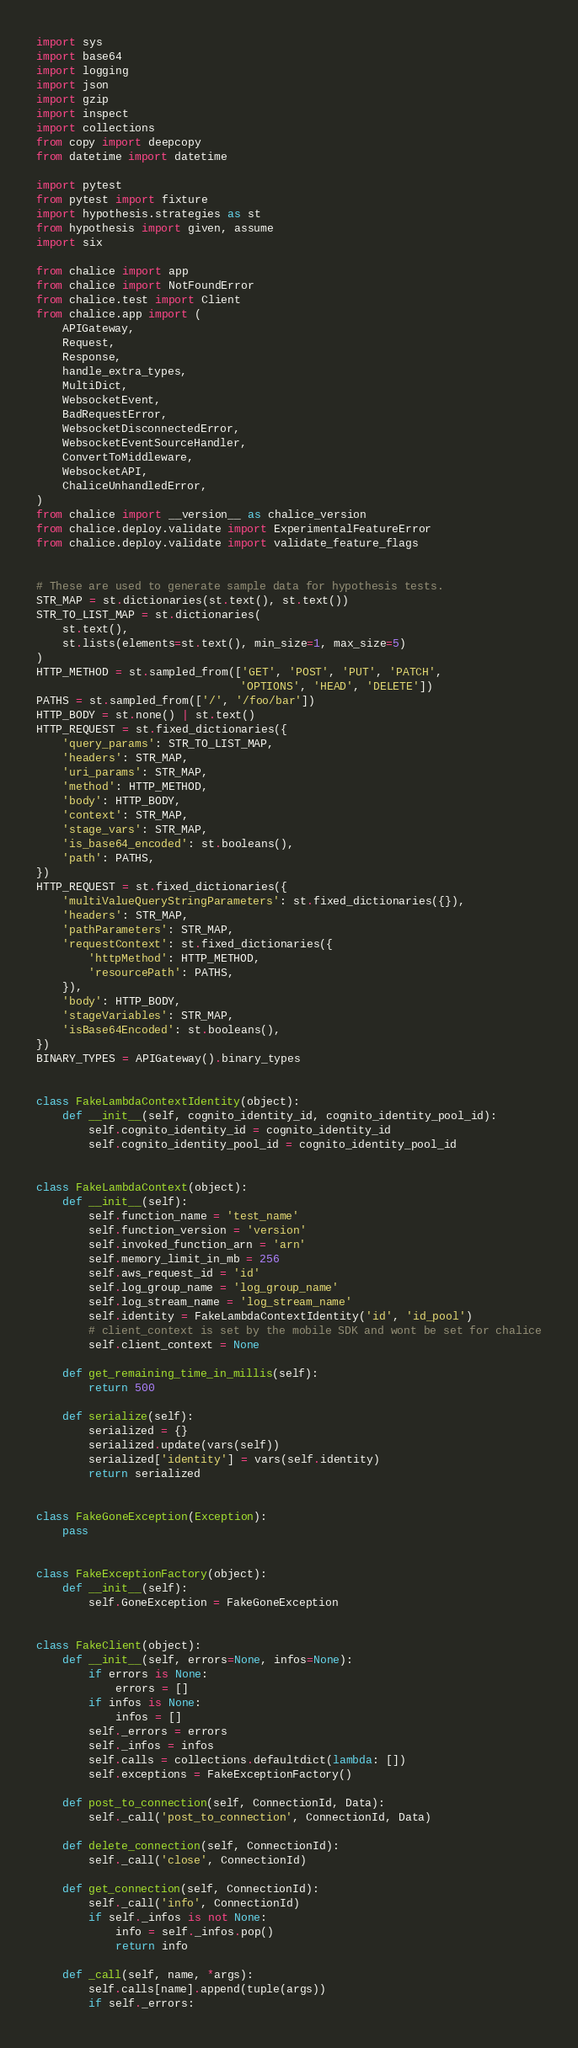Convert code to text. <code><loc_0><loc_0><loc_500><loc_500><_Python_>import sys
import base64
import logging
import json
import gzip
import inspect
import collections
from copy import deepcopy
from datetime import datetime

import pytest
from pytest import fixture
import hypothesis.strategies as st
from hypothesis import given, assume
import six

from chalice import app
from chalice import NotFoundError
from chalice.test import Client
from chalice.app import (
    APIGateway,
    Request,
    Response,
    handle_extra_types,
    MultiDict,
    WebsocketEvent,
    BadRequestError,
    WebsocketDisconnectedError,
    WebsocketEventSourceHandler,
    ConvertToMiddleware,
    WebsocketAPI,
    ChaliceUnhandledError,
)
from chalice import __version__ as chalice_version
from chalice.deploy.validate import ExperimentalFeatureError
from chalice.deploy.validate import validate_feature_flags


# These are used to generate sample data for hypothesis tests.
STR_MAP = st.dictionaries(st.text(), st.text())
STR_TO_LIST_MAP = st.dictionaries(
    st.text(),
    st.lists(elements=st.text(), min_size=1, max_size=5)
)
HTTP_METHOD = st.sampled_from(['GET', 'POST', 'PUT', 'PATCH',
                               'OPTIONS', 'HEAD', 'DELETE'])
PATHS = st.sampled_from(['/', '/foo/bar'])
HTTP_BODY = st.none() | st.text()
HTTP_REQUEST = st.fixed_dictionaries({
    'query_params': STR_TO_LIST_MAP,
    'headers': STR_MAP,
    'uri_params': STR_MAP,
    'method': HTTP_METHOD,
    'body': HTTP_BODY,
    'context': STR_MAP,
    'stage_vars': STR_MAP,
    'is_base64_encoded': st.booleans(),
    'path': PATHS,
})
HTTP_REQUEST = st.fixed_dictionaries({
    'multiValueQueryStringParameters': st.fixed_dictionaries({}),
    'headers': STR_MAP,
    'pathParameters': STR_MAP,
    'requestContext': st.fixed_dictionaries({
        'httpMethod': HTTP_METHOD,
        'resourcePath': PATHS,
    }),
    'body': HTTP_BODY,
    'stageVariables': STR_MAP,
    'isBase64Encoded': st.booleans(),
})
BINARY_TYPES = APIGateway().binary_types


class FakeLambdaContextIdentity(object):
    def __init__(self, cognito_identity_id, cognito_identity_pool_id):
        self.cognito_identity_id = cognito_identity_id
        self.cognito_identity_pool_id = cognito_identity_pool_id


class FakeLambdaContext(object):
    def __init__(self):
        self.function_name = 'test_name'
        self.function_version = 'version'
        self.invoked_function_arn = 'arn'
        self.memory_limit_in_mb = 256
        self.aws_request_id = 'id'
        self.log_group_name = 'log_group_name'
        self.log_stream_name = 'log_stream_name'
        self.identity = FakeLambdaContextIdentity('id', 'id_pool')
        # client_context is set by the mobile SDK and wont be set for chalice
        self.client_context = None

    def get_remaining_time_in_millis(self):
        return 500

    def serialize(self):
        serialized = {}
        serialized.update(vars(self))
        serialized['identity'] = vars(self.identity)
        return serialized


class FakeGoneException(Exception):
    pass


class FakeExceptionFactory(object):
    def __init__(self):
        self.GoneException = FakeGoneException


class FakeClient(object):
    def __init__(self, errors=None, infos=None):
        if errors is None:
            errors = []
        if infos is None:
            infos = []
        self._errors = errors
        self._infos = infos
        self.calls = collections.defaultdict(lambda: [])
        self.exceptions = FakeExceptionFactory()

    def post_to_connection(self, ConnectionId, Data):
        self._call('post_to_connection', ConnectionId, Data)

    def delete_connection(self, ConnectionId):
        self._call('close', ConnectionId)

    def get_connection(self, ConnectionId):
        self._call('info', ConnectionId)
        if self._infos is not None:
            info = self._infos.pop()
            return info

    def _call(self, name, *args):
        self.calls[name].append(tuple(args))
        if self._errors:</code> 